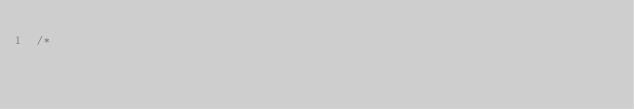<code> <loc_0><loc_0><loc_500><loc_500><_Java_>/*</code> 